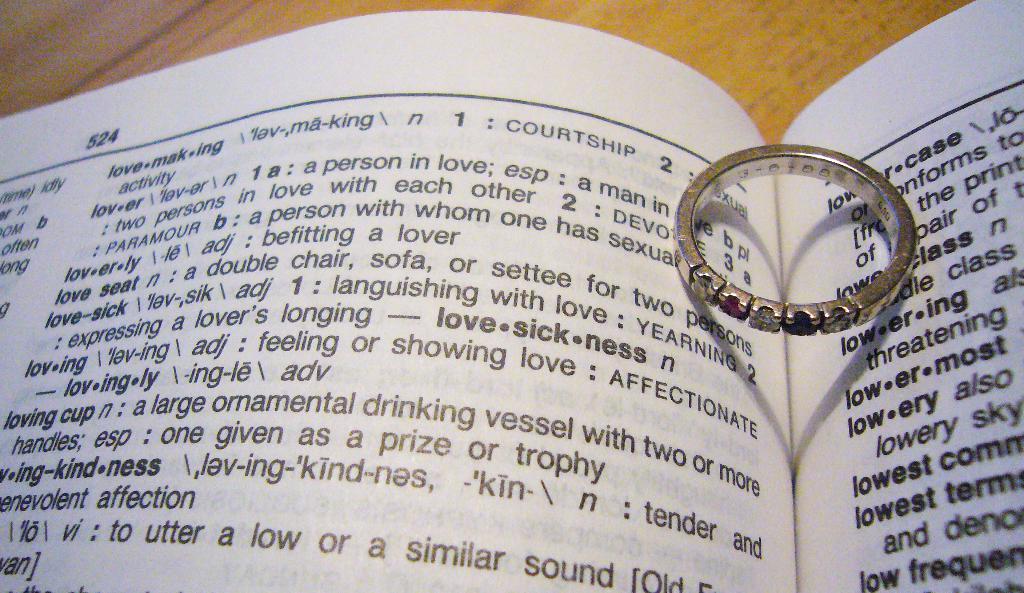What is the page number?
Keep it short and to the point. 524. 